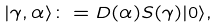Convert formula to latex. <formula><loc_0><loc_0><loc_500><loc_500>| \gamma , \alpha \rangle \colon = D ( \alpha ) S ( \gamma ) | 0 \rangle ,</formula> 